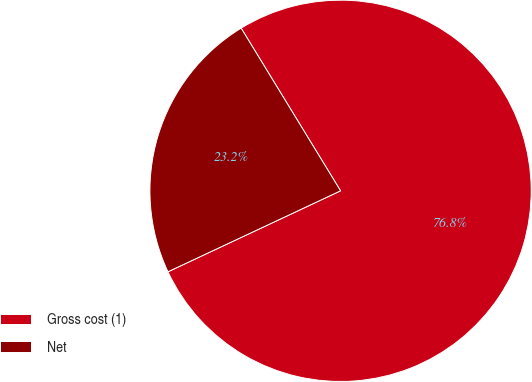Convert chart to OTSL. <chart><loc_0><loc_0><loc_500><loc_500><pie_chart><fcel>Gross cost (1)<fcel>Net<nl><fcel>76.75%<fcel>23.25%<nl></chart> 